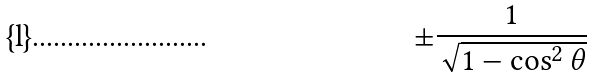Convert formula to latex. <formula><loc_0><loc_0><loc_500><loc_500>\pm \frac { 1 } { \sqrt { 1 - \cos ^ { 2 } \theta } }</formula> 